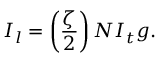Convert formula to latex. <formula><loc_0><loc_0><loc_500><loc_500>I _ { l } = \left ( \frac { \zeta } { 2 } \right ) N I _ { t } g .</formula> 